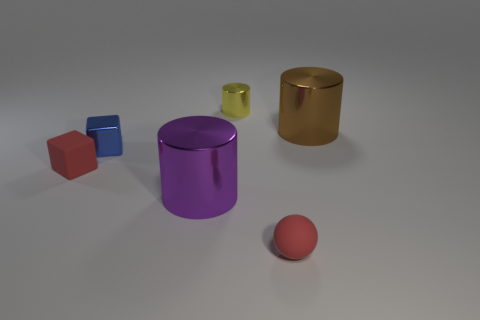There is a red thing that is the same shape as the blue metal thing; what is it made of?
Your answer should be compact. Rubber. What is the shape of the small thing that is on the right side of the small blue object and behind the tiny red rubber sphere?
Offer a very short reply. Cylinder. What shape is the tiny yellow thing that is made of the same material as the big purple cylinder?
Give a very brief answer. Cylinder. What is the cylinder behind the brown thing made of?
Offer a very short reply. Metal. Is the size of the red thing to the left of the tiny yellow metal thing the same as the object that is behind the large brown metallic cylinder?
Make the answer very short. Yes. What is the color of the rubber ball?
Provide a short and direct response. Red. There is a small rubber thing right of the small blue metal block; is its shape the same as the big brown metal thing?
Your response must be concise. No. What is the small yellow thing made of?
Offer a terse response. Metal. What shape is the blue object that is the same size as the sphere?
Your response must be concise. Cube. Are there any other tiny balls that have the same color as the rubber ball?
Your response must be concise. No. 